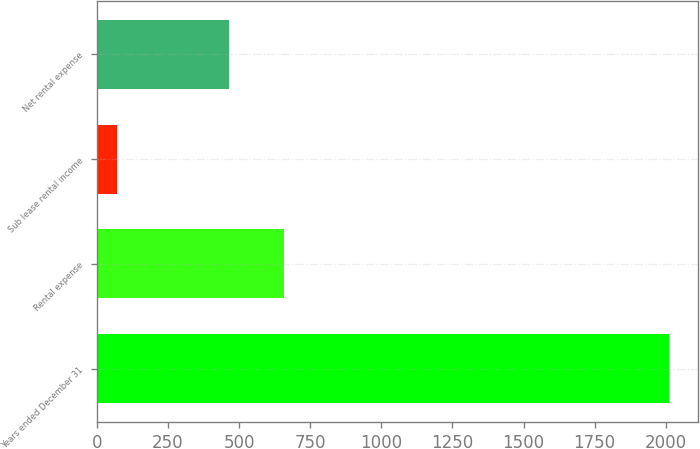Convert chart. <chart><loc_0><loc_0><loc_500><loc_500><bar_chart><fcel>Years ended December 31<fcel>Rental expense<fcel>Sub lease rental income<fcel>Net rental expense<nl><fcel>2012<fcel>658<fcel>72<fcel>464<nl></chart> 